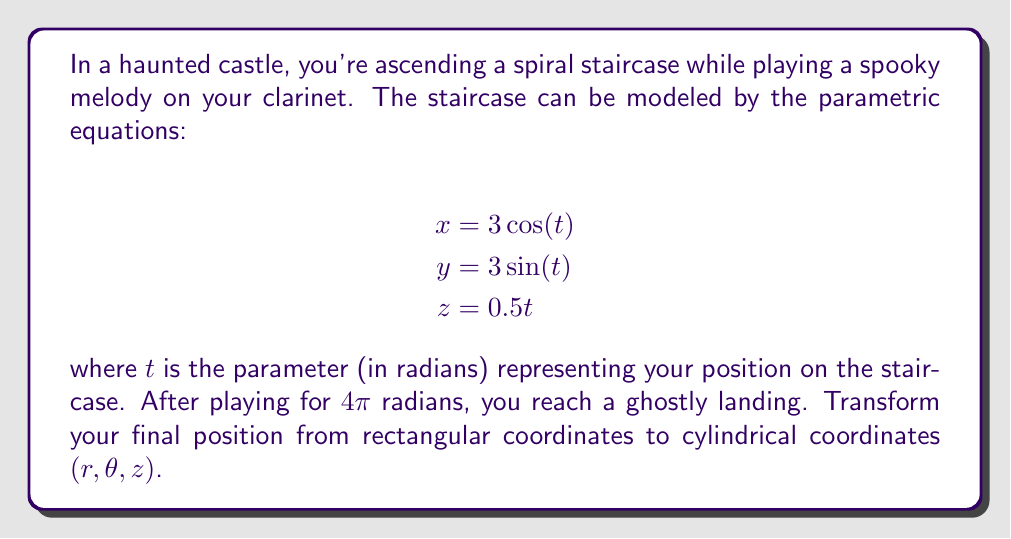Provide a solution to this math problem. To transform rectangular coordinates $(x, y, z)$ to cylindrical coordinates $(r, \theta, z)$, we use the following relationships:

1. $r = \sqrt{x^2 + y^2}$
2. $\theta = \tan^{-1}(\frac{y}{x})$
3. $z$ remains the same

Let's solve this step-by-step:

1. Find the final position in rectangular coordinates:
   At $t = 4\pi$:
   $$x = 3\cos(4\pi) = 3$$
   $$y = 3\sin(4\pi) = 0$$
   $$z = 0.5(4\pi) = 2\pi$$

2. Calculate $r$:
   $$r = \sqrt{x^2 + y^2} = \sqrt{3^2 + 0^2} = 3$$

3. Calculate $\theta$:
   $$\theta = \tan^{-1}(\frac{y}{x}) = \tan^{-1}(\frac{0}{3}) = 0$$

4. The $z$ coordinate remains $2\pi$.

Therefore, the final position in cylindrical coordinates is $(3, 0, 2\pi)$.
Answer: $(3, 0, 2\pi)$ 